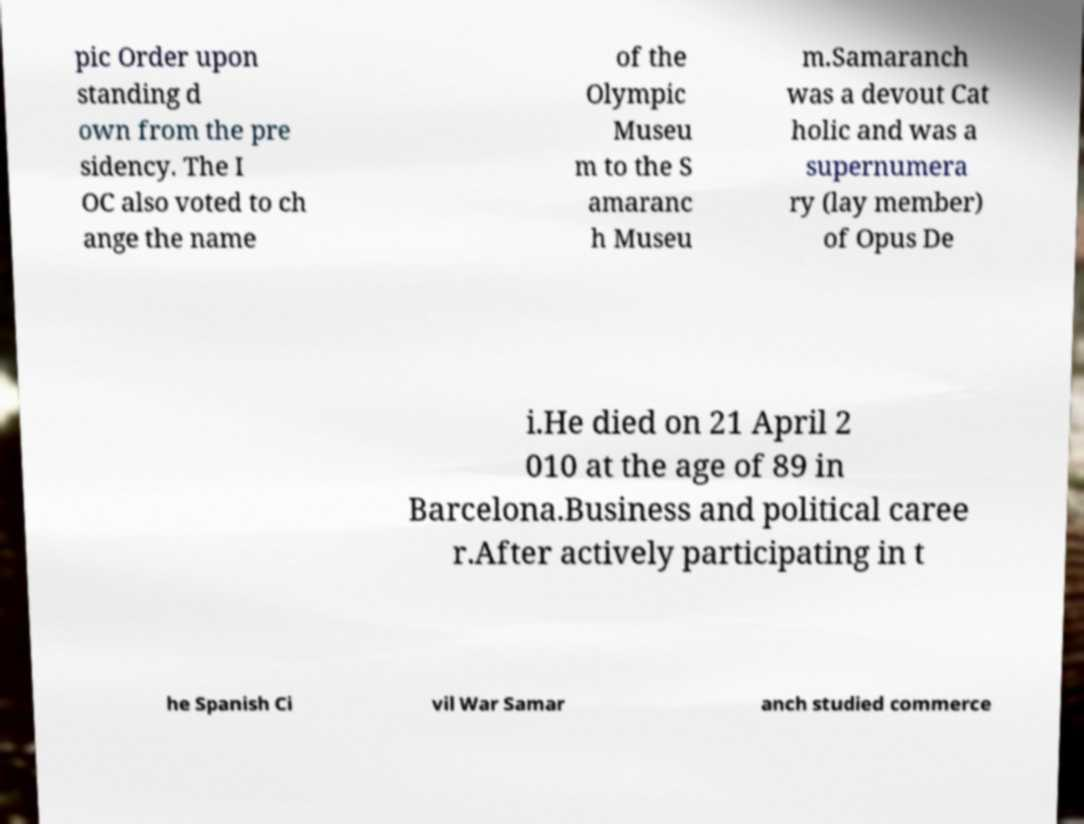Please read and relay the text visible in this image. What does it say? pic Order upon standing d own from the pre sidency. The I OC also voted to ch ange the name of the Olympic Museu m to the S amaranc h Museu m.Samaranch was a devout Cat holic and was a supernumera ry (lay member) of Opus De i.He died on 21 April 2 010 at the age of 89 in Barcelona.Business and political caree r.After actively participating in t he Spanish Ci vil War Samar anch studied commerce 